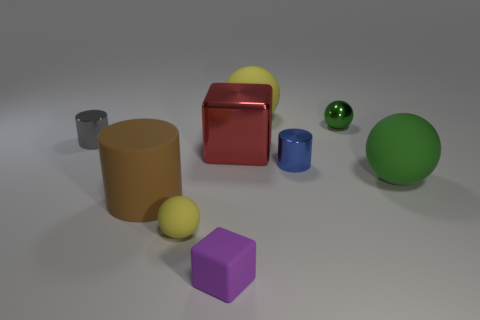Subtract all yellow blocks. How many green spheres are left? 2 Subtract all small rubber spheres. How many spheres are left? 3 Add 1 tiny gray metal things. How many objects exist? 10 Subtract all gray spheres. Subtract all blue cylinders. How many spheres are left? 4 Subtract 1 red blocks. How many objects are left? 8 Subtract all cylinders. How many objects are left? 6 Subtract all large purple blocks. Subtract all tiny gray metal objects. How many objects are left? 8 Add 8 purple matte blocks. How many purple matte blocks are left? 9 Add 8 small cubes. How many small cubes exist? 9 